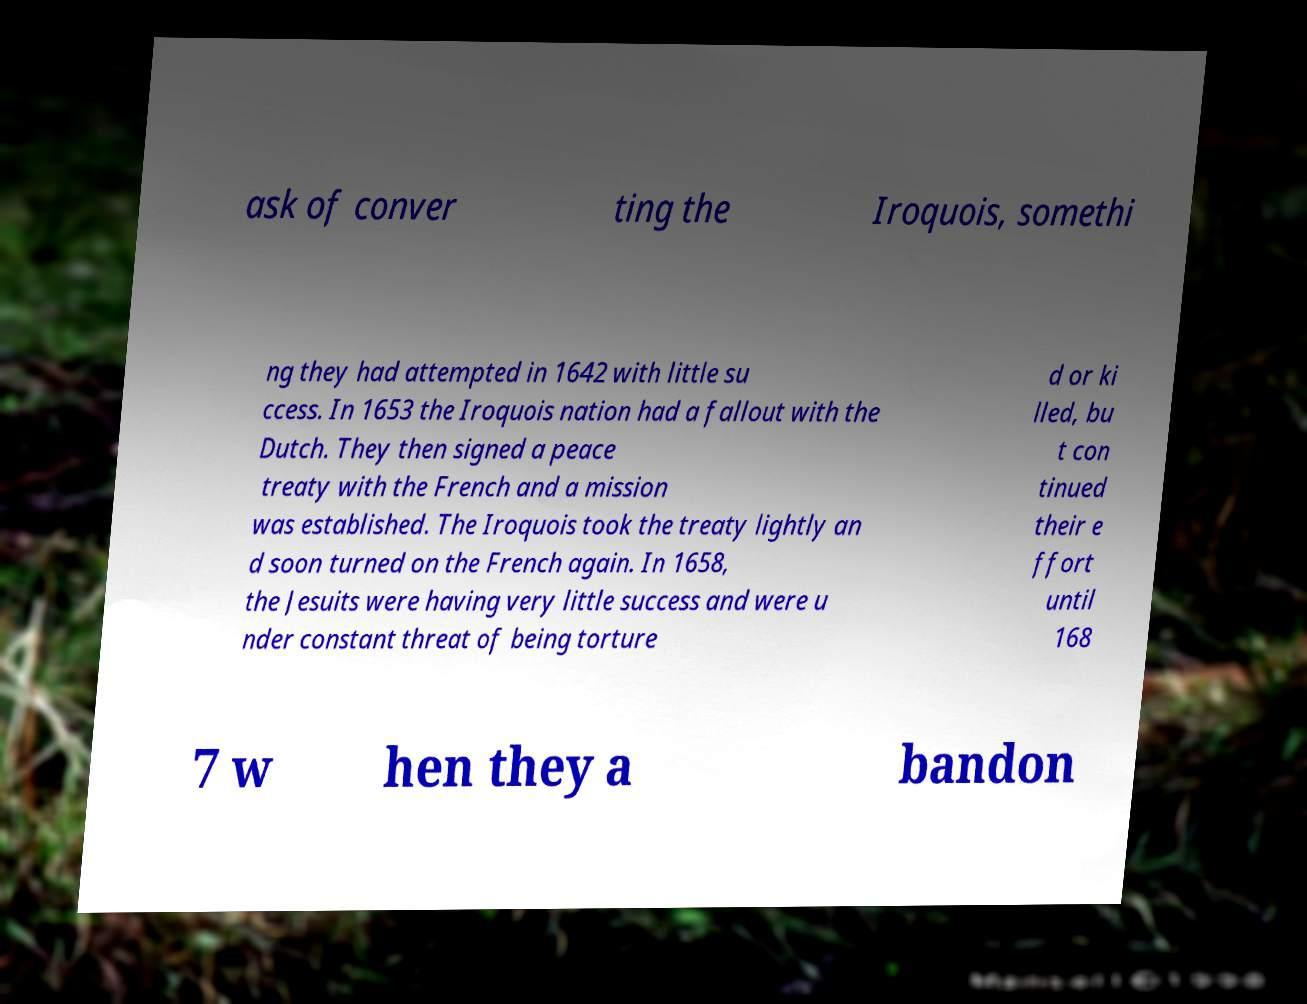There's text embedded in this image that I need extracted. Can you transcribe it verbatim? ask of conver ting the Iroquois, somethi ng they had attempted in 1642 with little su ccess. In 1653 the Iroquois nation had a fallout with the Dutch. They then signed a peace treaty with the French and a mission was established. The Iroquois took the treaty lightly an d soon turned on the French again. In 1658, the Jesuits were having very little success and were u nder constant threat of being torture d or ki lled, bu t con tinued their e ffort until 168 7 w hen they a bandon 